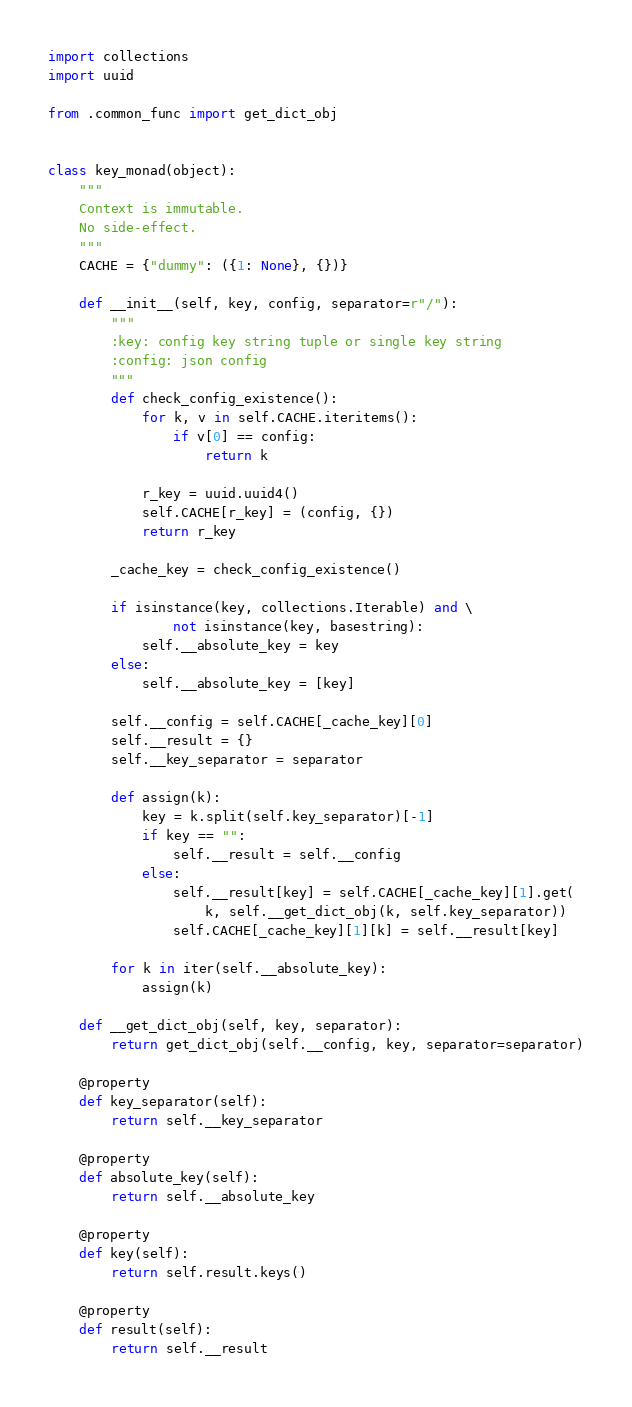<code> <loc_0><loc_0><loc_500><loc_500><_Python_>import collections
import uuid

from .common_func import get_dict_obj


class key_monad(object):
    """
    Context is immutable.
    No side-effect.
    """
    CACHE = {"dummy": ({1: None}, {})}

    def __init__(self, key, config, separator=r"/"):
        """
        :key: config key string tuple or single key string
        :config: json config
        """
        def check_config_existence():
            for k, v in self.CACHE.iteritems():
                if v[0] == config:
                    return k

            r_key = uuid.uuid4()
            self.CACHE[r_key] = (config, {})
            return r_key

        _cache_key = check_config_existence()

        if isinstance(key, collections.Iterable) and \
                not isinstance(key, basestring):
            self.__absolute_key = key
        else:
            self.__absolute_key = [key]

        self.__config = self.CACHE[_cache_key][0]
        self.__result = {}
        self.__key_separator = separator

        def assign(k):
            key = k.split(self.key_separator)[-1]
            if key == "":
                self.__result = self.__config
            else:
                self.__result[key] = self.CACHE[_cache_key][1].get(
                    k, self.__get_dict_obj(k, self.key_separator))
                self.CACHE[_cache_key][1][k] = self.__result[key]

        for k in iter(self.__absolute_key):
            assign(k)

    def __get_dict_obj(self, key, separator):
        return get_dict_obj(self.__config, key, separator=separator)

    @property
    def key_separator(self):
        return self.__key_separator

    @property
    def absolute_key(self):
        return self.__absolute_key

    @property
    def key(self):
        return self.result.keys()

    @property
    def result(self):
        return self.__result
</code> 